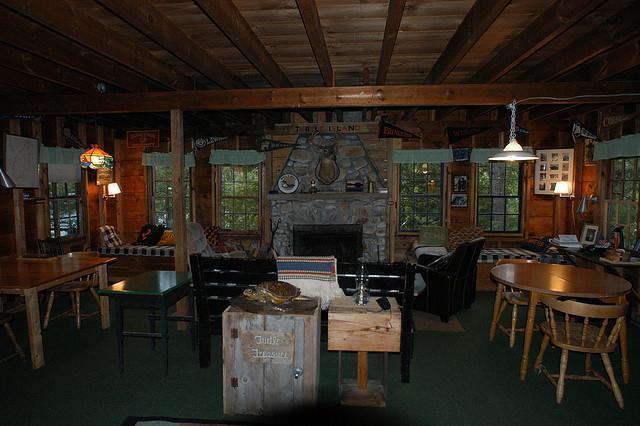How many light fixtures are on?
Give a very brief answer. 4. How many chairs are visible?
Give a very brief answer. 3. How many dining tables are there?
Give a very brief answer. 2. 